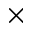Convert formula to latex. <formula><loc_0><loc_0><loc_500><loc_500>\times</formula> 